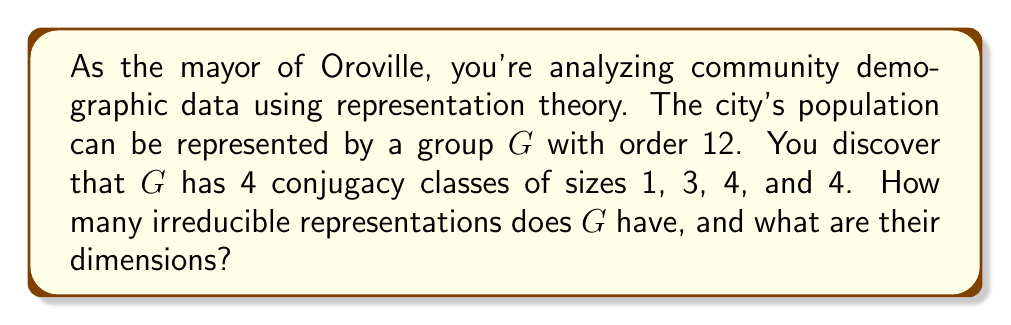What is the answer to this math problem? Let's approach this step-by-step using representation theory:

1) First, recall that the number of irreducible representations of a group is equal to the number of conjugacy classes. Here, we have 4 conjugacy classes, so $G$ has 4 irreducible representations.

2) Let's denote the dimensions of these irreducible representations as $d_1, d_2, d_3,$ and $d_4$.

3) We can use the formula for the order of the group:

   $$|G| = \sum_{i=1}^k d_i^2$$

   where $k$ is the number of irreducible representations.

4) We know $|G| = 12$, so:

   $$12 = d_1^2 + d_2^2 + d_3^2 + d_4^2$$

5) We also know that one of these dimensions must be 1, corresponding to the trivial representation. Let's say $d_1 = 1$.

6) Now we have:

   $$11 = d_2^2 + d_3^2 + d_4^2$$

7) The only way to decompose 11 into a sum of three perfect squares is:

   $$11 = 1^2 + 2^2 + 2^2$$

8) Therefore, the dimensions of the irreducible representations are 1, 1, 2, and 2.

9) We can verify this using the class equation:

   $$|G| = \sum_{i=1}^k |C_i|$$

   where $|C_i|$ are the sizes of the conjugacy classes.

   Indeed, $12 = 1 + 3 + 4 + 4$

This solution provides valuable insight into the structure of your community's demographic data, allowing for more informed decision-making as the mayor of Oroville.
Answer: 4 irreducible representations with dimensions 1, 1, 2, and 2 